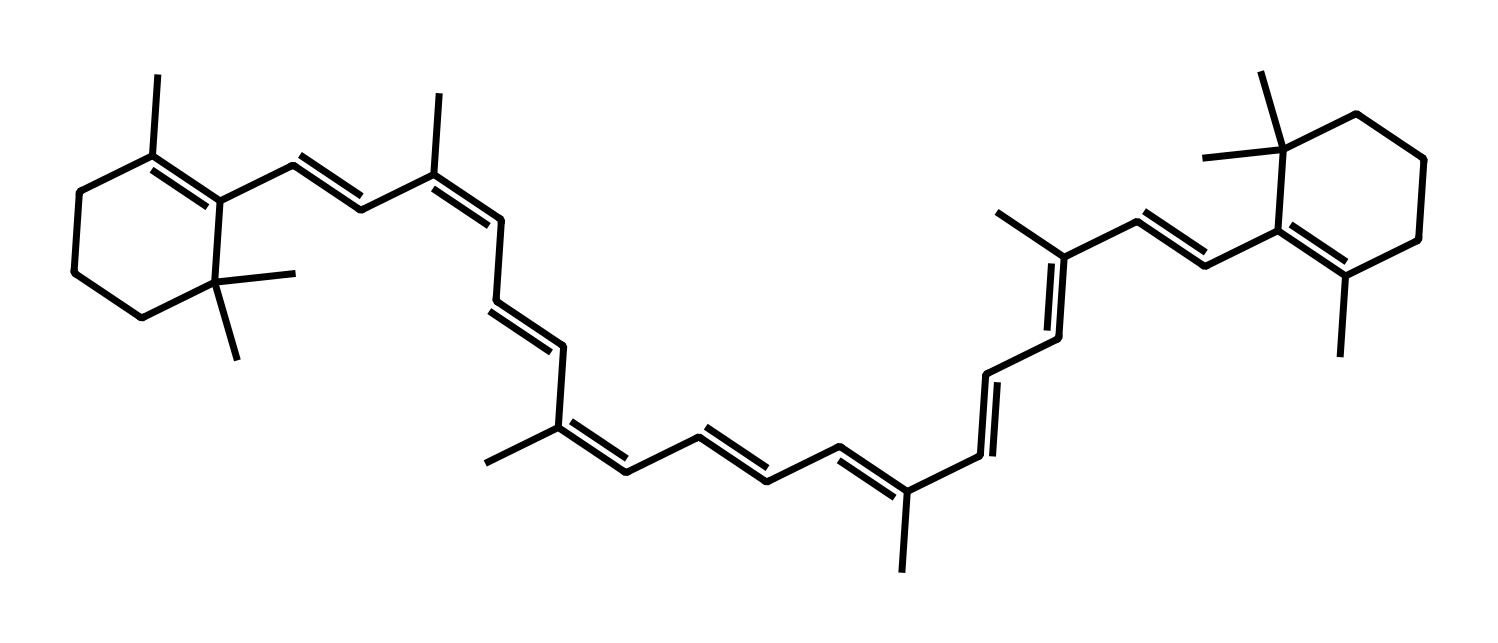How many carbon atoms are present in beta-carotene? To find the number of carbon atoms in the molecule, we can count the “C” symbols in the SMILES representation. By carefully analyzing the SMILES, we arrive at a total of 40 carbon atoms.
Answer: 40 What is the degree of unsaturation in beta-carotene? The degree of unsaturation can be calculated using the formula: (2C + 2 + N - H - X)/2. In this case, with 40 carbon atoms and 56 hydrogen atoms from the structure, we find that the degree of unsaturation is 10.
Answer: 10 What is the structural feature that classifies beta-carotene as a carotenoid? Beta-carotene features a long conjugated system, which consists of alternating double and single bonds. This conjugation is the hallmark of carotenoids, which are responsible for the orange pigment in carrots.
Answer: conjugated double bonds Does beta-carotene exhibit antioxidant properties? Yes, beta-carotene is known for its antioxidant properties, which are due to its ability to donate electrons and neutralize free radicals, protecting cells from oxidative damage.
Answer: yes What type of bond primarily stabilizes the molecular structure of beta-carotene? The primary type of bond that stabilizes the structure is the covalent bond. This is evident from the connections between carbon atoms in the hydrocarbon framework of beta-carotene.
Answer: covalent bond 